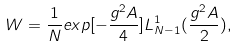Convert formula to latex. <formula><loc_0><loc_0><loc_500><loc_500>W = \frac { 1 } { N } e x p [ - \frac { g ^ { 2 } A } { 4 } ] L _ { N - 1 } ^ { 1 } ( \frac { g ^ { 2 } A } { 2 } ) ,</formula> 